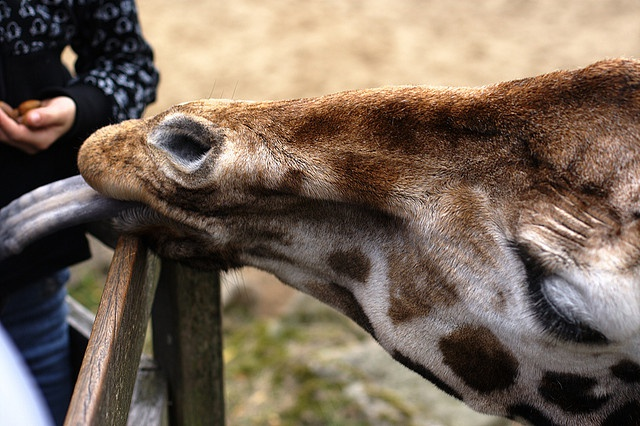Describe the objects in this image and their specific colors. I can see giraffe in black, gray, and maroon tones and people in black, gray, and brown tones in this image. 